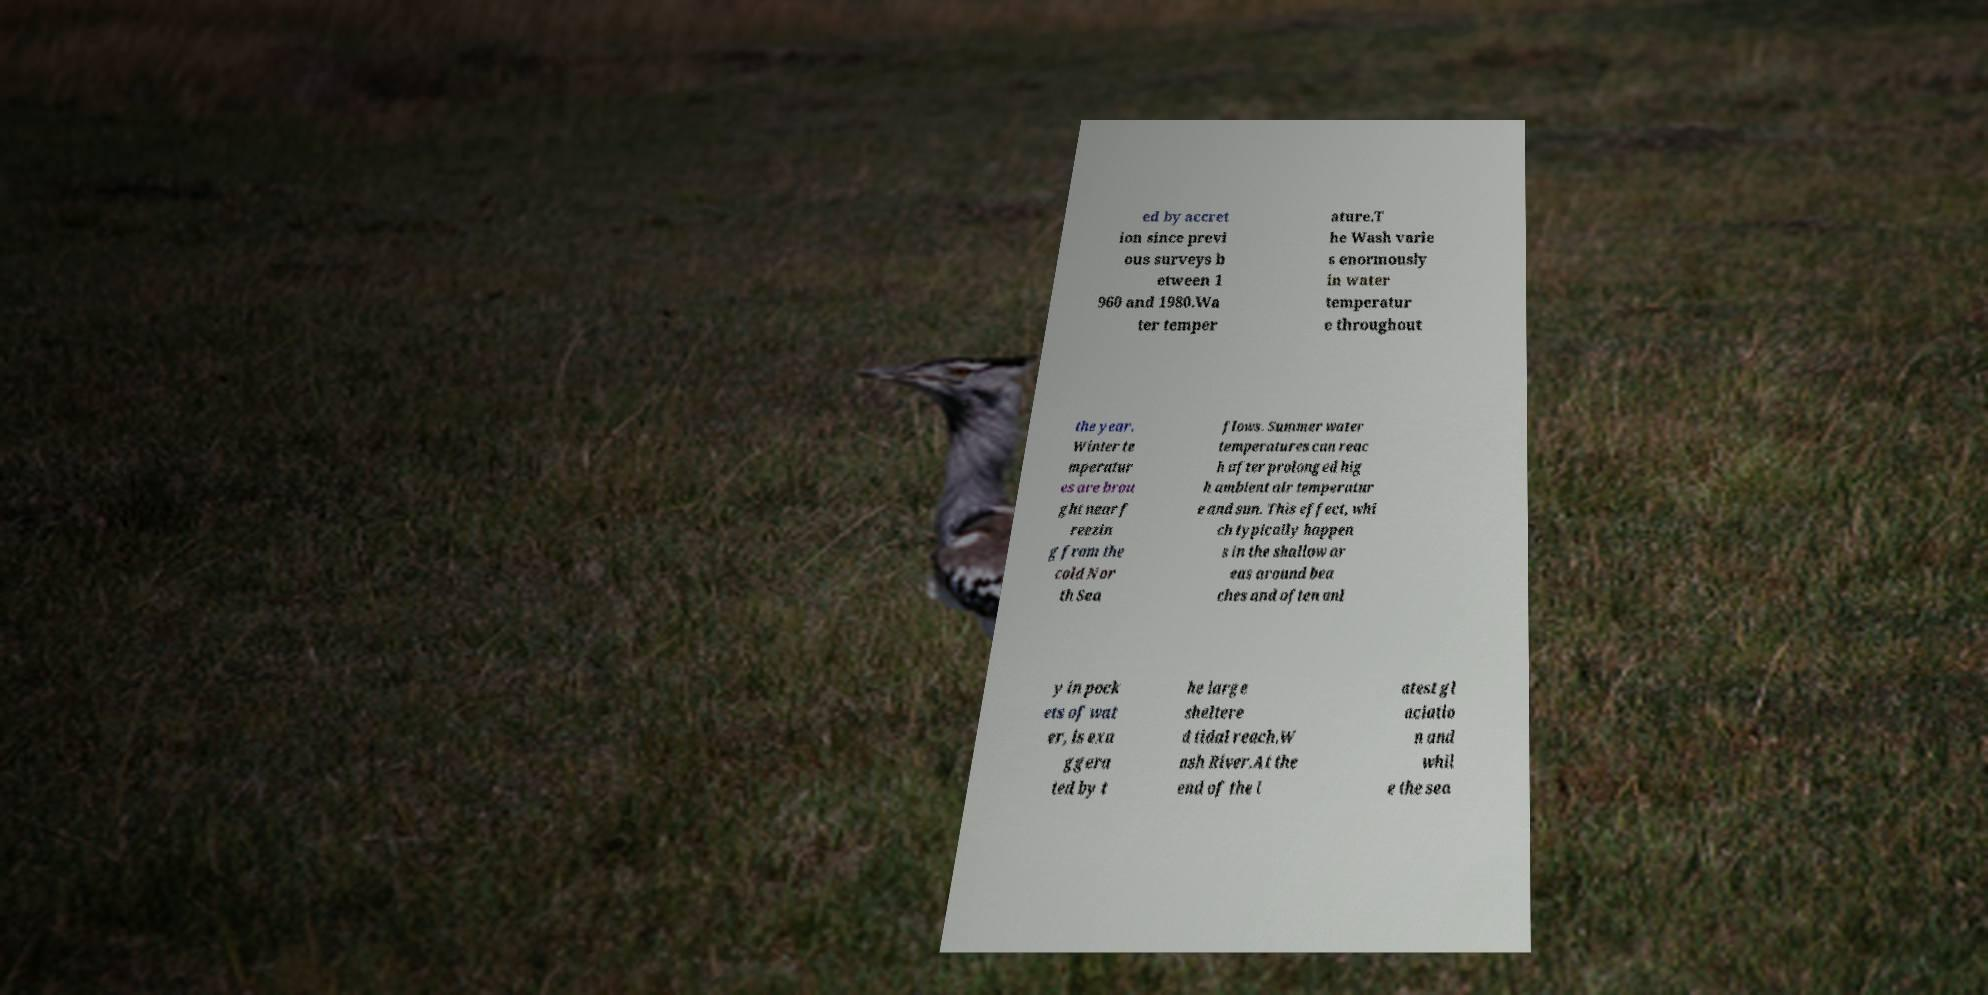Can you accurately transcribe the text from the provided image for me? ed by accret ion since previ ous surveys b etween 1 960 and 1980.Wa ter temper ature.T he Wash varie s enormously in water temperatur e throughout the year. Winter te mperatur es are brou ght near f reezin g from the cold Nor th Sea flows. Summer water temperatures can reac h after prolonged hig h ambient air temperatur e and sun. This effect, whi ch typically happen s in the shallow ar eas around bea ches and often onl y in pock ets of wat er, is exa ggera ted by t he large sheltere d tidal reach.W ash River.At the end of the l atest gl aciatio n and whil e the sea 